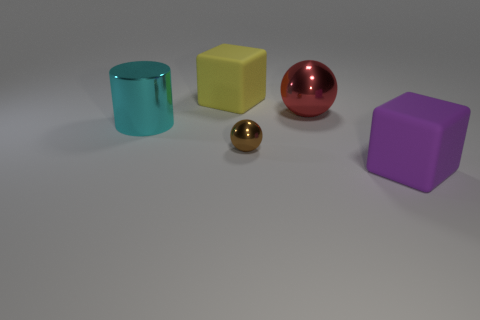Add 3 large metallic cylinders. How many objects exist? 8 Subtract all cubes. How many objects are left? 3 Add 3 big rubber cubes. How many big rubber cubes are left? 5 Add 4 red shiny objects. How many red shiny objects exist? 5 Subtract 0 red cylinders. How many objects are left? 5 Subtract all purple blocks. Subtract all yellow blocks. How many objects are left? 3 